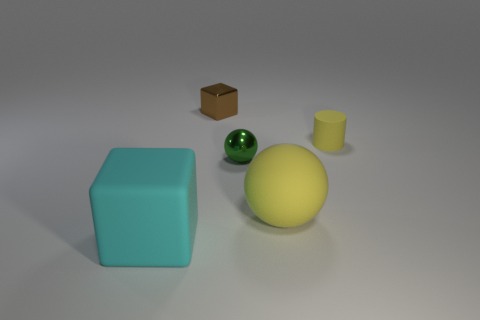There is a large thing on the left side of the small brown metallic object; is its shape the same as the tiny metallic object that is behind the tiny green metal sphere?
Keep it short and to the point. Yes. What shape is the large object that is the same color as the tiny rubber thing?
Your answer should be compact. Sphere. What number of things are either green objects that are to the right of the small brown object or large objects?
Your response must be concise. 3. Is the green metal sphere the same size as the cyan rubber block?
Offer a very short reply. No. The block behind the green metal ball is what color?
Provide a short and direct response. Brown. What size is the yellow thing that is made of the same material as the tiny yellow cylinder?
Give a very brief answer. Large. There is a yellow rubber sphere; is it the same size as the block behind the large matte block?
Offer a very short reply. No. There is a cube that is behind the large cyan matte block; what material is it?
Offer a very short reply. Metal. There is a yellow thing that is in front of the small yellow matte cylinder; how many small brown shiny objects are in front of it?
Your answer should be compact. 0. Is there a tiny metallic object of the same shape as the large cyan matte thing?
Give a very brief answer. Yes. 